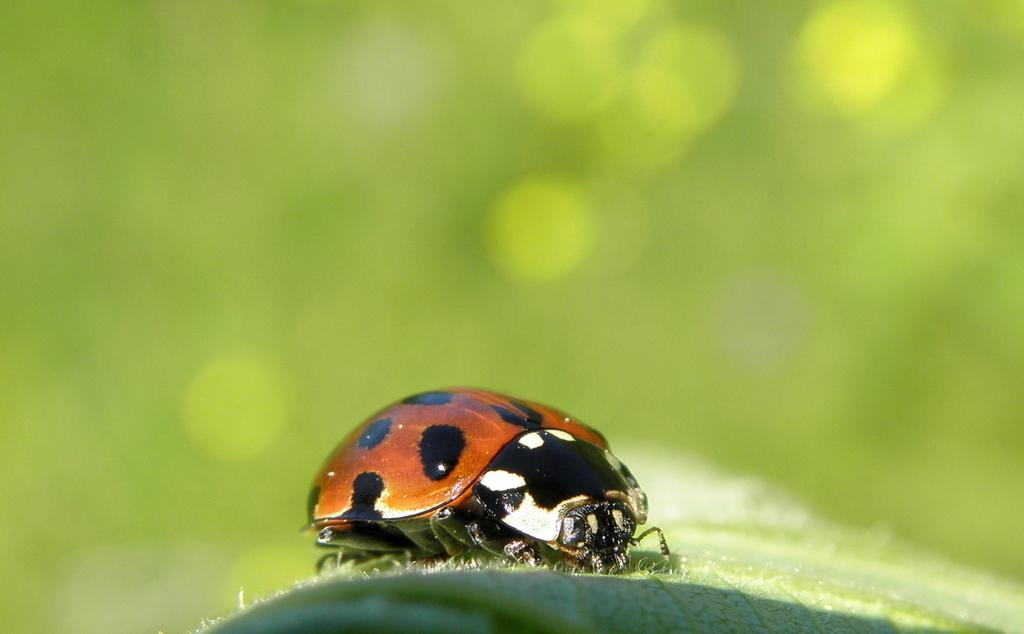What is the main subject of the image? There is a leaf in the image. Is there anything else on the leaf? Yes, an insect is present on the leaf. What color is the background of the image? The background of the image is green. How is the background of the image depicted? The background of the image is blurred. How many passengers are visible on the leaf in the image? There are no passengers present in the image; it features a leaf with an insect on it. Is there a maid visible in the image? There is no maid present in the image. 